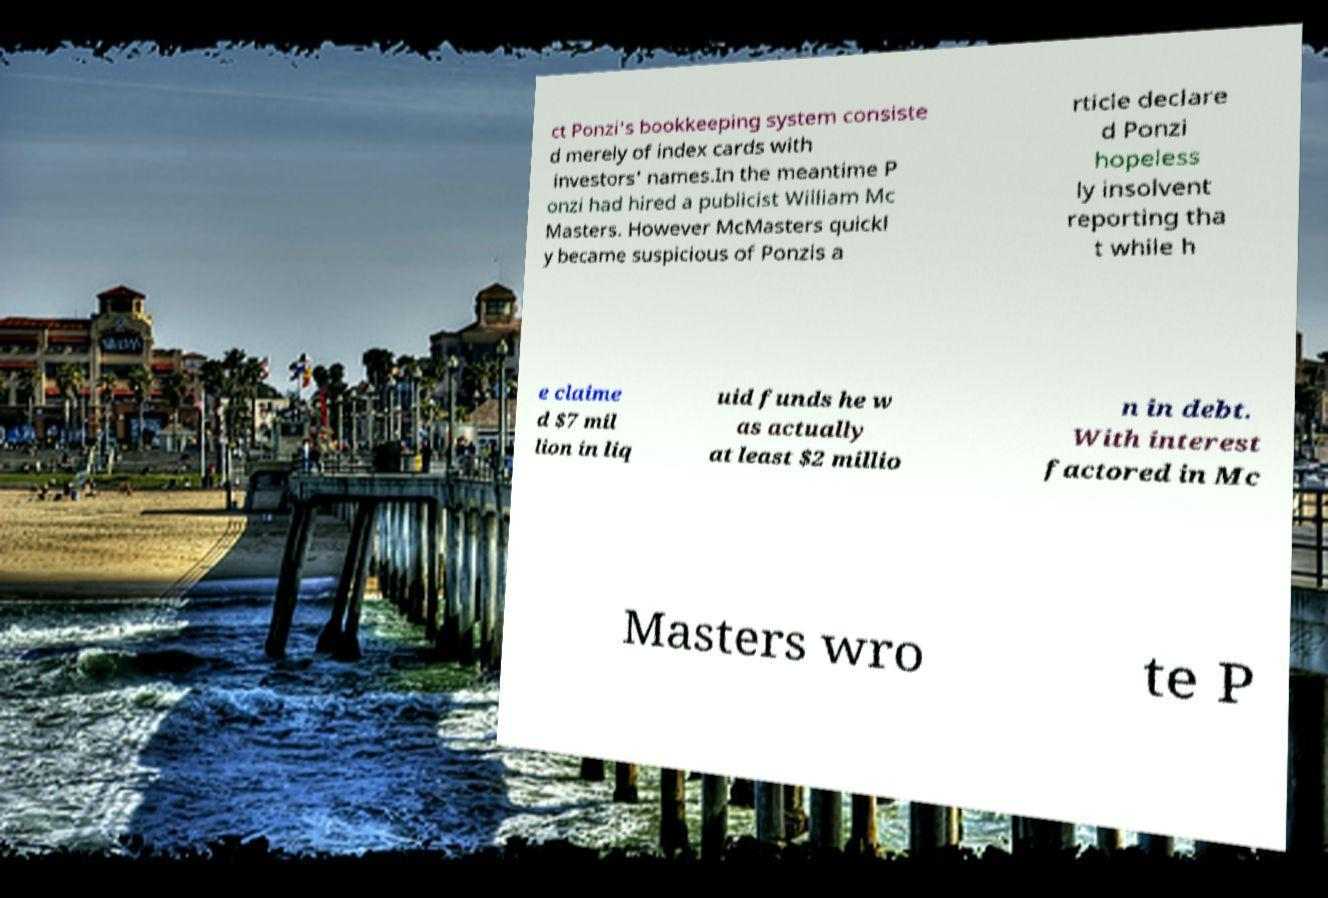Could you assist in decoding the text presented in this image and type it out clearly? ct Ponzi's bookkeeping system consiste d merely of index cards with investors' names.In the meantime P onzi had hired a publicist William Mc Masters. However McMasters quickl y became suspicious of Ponzis a rticle declare d Ponzi hopeless ly insolvent reporting tha t while h e claime d $7 mil lion in liq uid funds he w as actually at least $2 millio n in debt. With interest factored in Mc Masters wro te P 